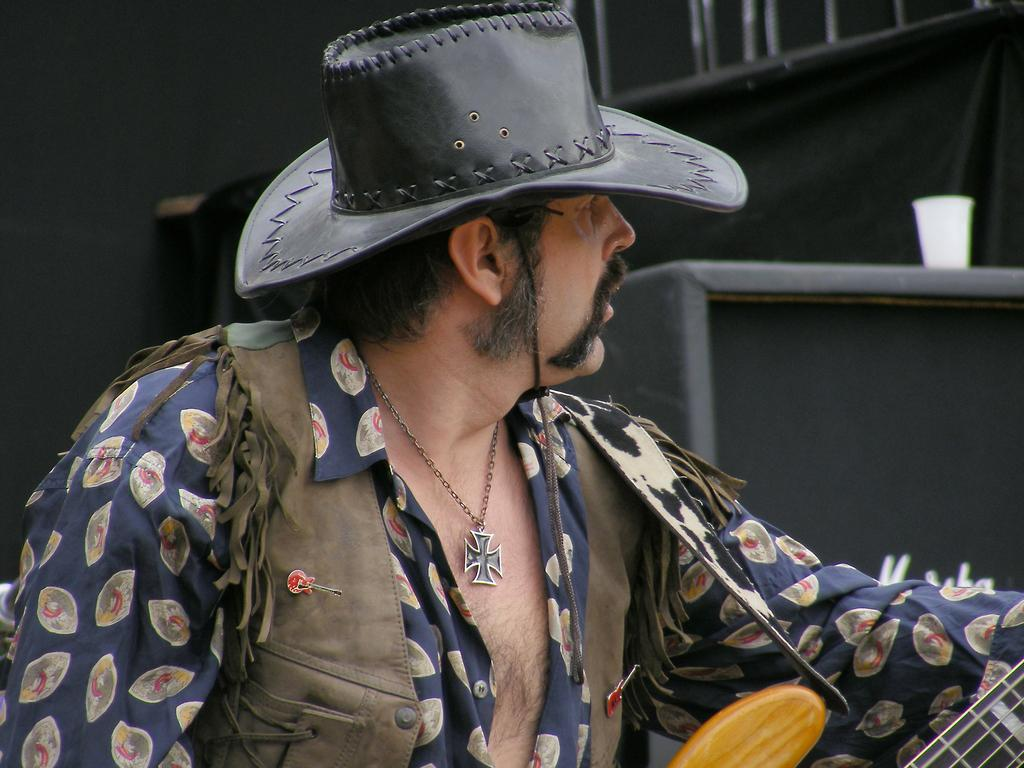What is the person in the image doing? The person is playing a guitar. What direction is the person looking in the image? The person is looking to the right side of the image. What type of crate is the person sitting on in the image? There is no crate present in the image; the person is standing while playing the guitar. What kind of snake is wrapped around the person's neck in the image? There is no snake present in the image; the person is simply playing the guitar without any additional objects or animals. 